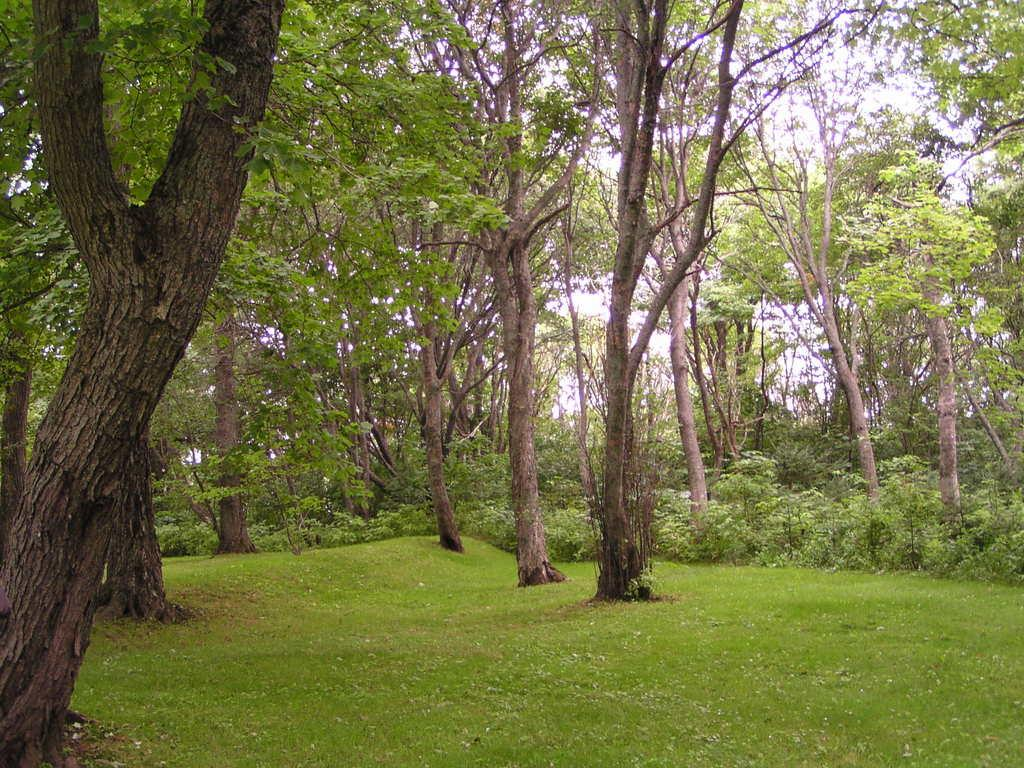What type of vegetation is present in the image? There is grass in the image. What other natural elements can be seen in the image? There are trees in the image. What is visible in the background of the image? The sky is visible in the background of the image. What decision does the doctor make in the image? There is no doctor or decision-making process depicted in the image; it features grass, trees, and the sky. 